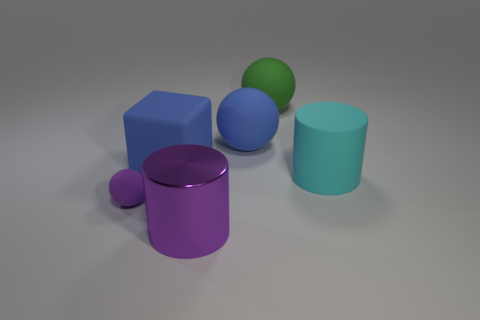Add 1 big metallic cylinders. How many objects exist? 7 Subtract all big rubber spheres. How many spheres are left? 1 Subtract all cylinders. How many objects are left? 4 Add 6 large blue spheres. How many large blue spheres exist? 7 Subtract 1 green balls. How many objects are left? 5 Subtract all yellow spheres. Subtract all blue cubes. How many spheres are left? 3 Subtract all big purple cubes. Subtract all green rubber objects. How many objects are left? 5 Add 5 large blue matte spheres. How many large blue matte spheres are left? 6 